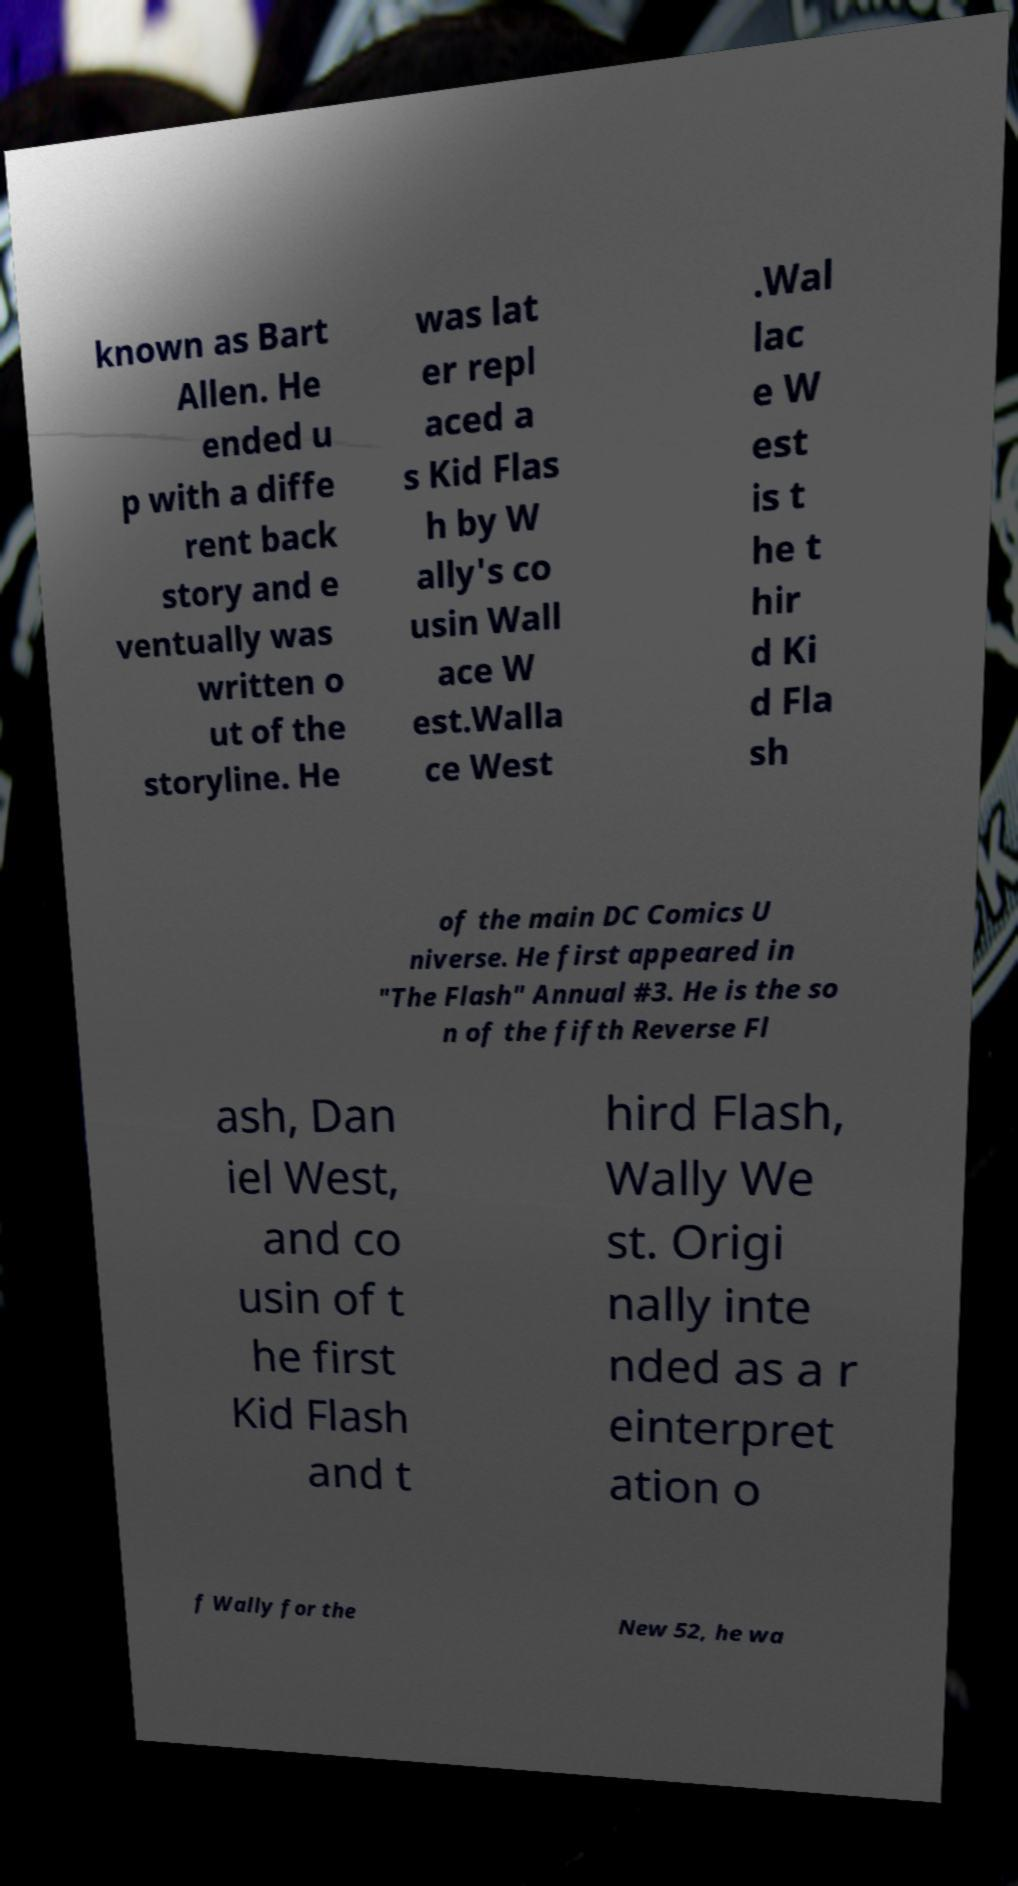Could you assist in decoding the text presented in this image and type it out clearly? known as Bart Allen. He ended u p with a diffe rent back story and e ventually was written o ut of the storyline. He was lat er repl aced a s Kid Flas h by W ally's co usin Wall ace W est.Walla ce West .Wal lac e W est is t he t hir d Ki d Fla sh of the main DC Comics U niverse. He first appeared in "The Flash" Annual #3. He is the so n of the fifth Reverse Fl ash, Dan iel West, and co usin of t he first Kid Flash and t hird Flash, Wally We st. Origi nally inte nded as a r einterpret ation o f Wally for the New 52, he wa 